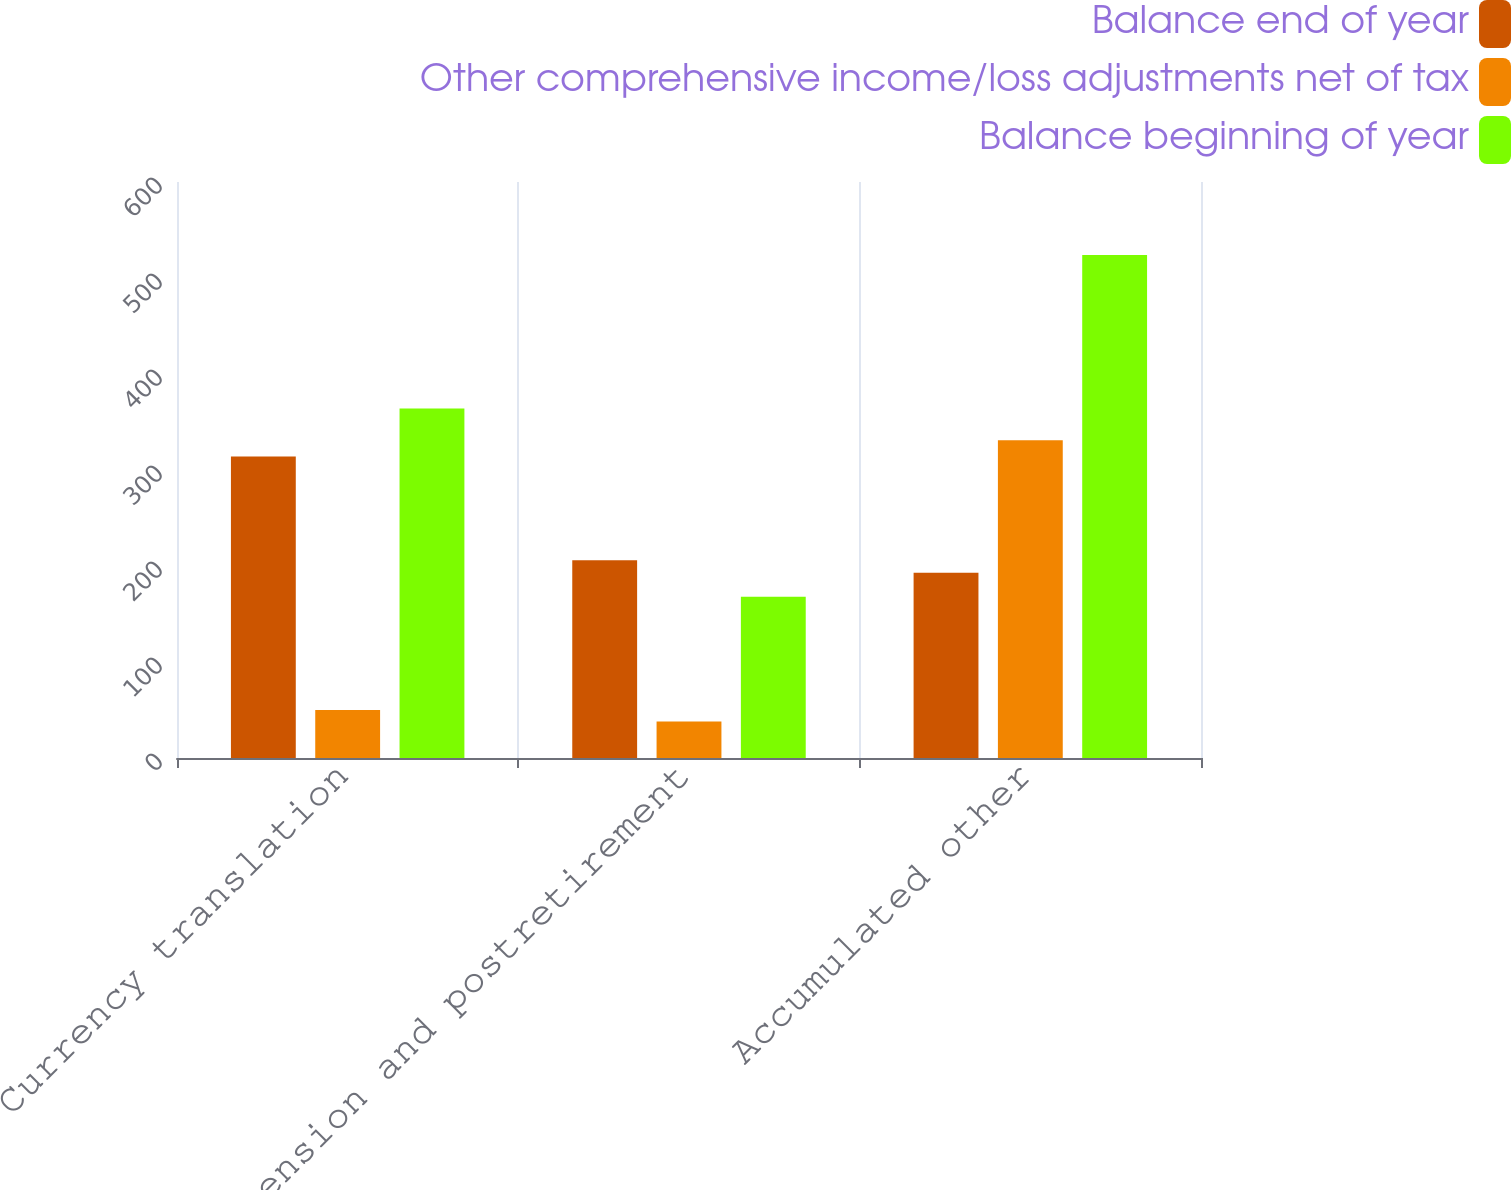Convert chart to OTSL. <chart><loc_0><loc_0><loc_500><loc_500><stacked_bar_chart><ecel><fcel>Currency translation<fcel>Pension and postretirement<fcel>Accumulated other<nl><fcel>Balance end of year<fcel>314<fcel>206<fcel>193<nl><fcel>Other comprehensive income/loss adjustments net of tax<fcel>50<fcel>38<fcel>331<nl><fcel>Balance beginning of year<fcel>364<fcel>168<fcel>524<nl></chart> 